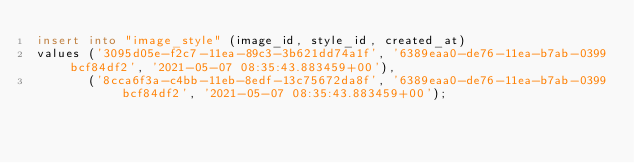Convert code to text. <code><loc_0><loc_0><loc_500><loc_500><_SQL_>insert into "image_style" (image_id, style_id, created_at)
values ('3095d05e-f2c7-11ea-89c3-3b621dd74a1f', '6389eaa0-de76-11ea-b7ab-0399bcf84df2', '2021-05-07 08:35:43.883459+00'),
       ('8cca6f3a-c4bb-11eb-8edf-13c75672da8f', '6389eaa0-de76-11ea-b7ab-0399bcf84df2', '2021-05-07 08:35:43.883459+00');
</code> 